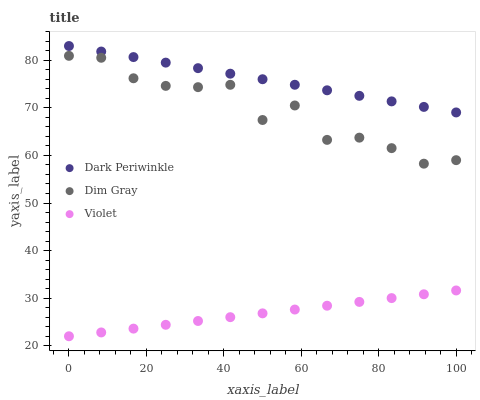Does Violet have the minimum area under the curve?
Answer yes or no. Yes. Does Dark Periwinkle have the maximum area under the curve?
Answer yes or no. Yes. Does Dark Periwinkle have the minimum area under the curve?
Answer yes or no. No. Does Violet have the maximum area under the curve?
Answer yes or no. No. Is Violet the smoothest?
Answer yes or no. Yes. Is Dim Gray the roughest?
Answer yes or no. Yes. Is Dark Periwinkle the smoothest?
Answer yes or no. No. Is Dark Periwinkle the roughest?
Answer yes or no. No. Does Violet have the lowest value?
Answer yes or no. Yes. Does Dark Periwinkle have the lowest value?
Answer yes or no. No. Does Dark Periwinkle have the highest value?
Answer yes or no. Yes. Does Violet have the highest value?
Answer yes or no. No. Is Dim Gray less than Dark Periwinkle?
Answer yes or no. Yes. Is Dark Periwinkle greater than Violet?
Answer yes or no. Yes. Does Dim Gray intersect Dark Periwinkle?
Answer yes or no. No. 